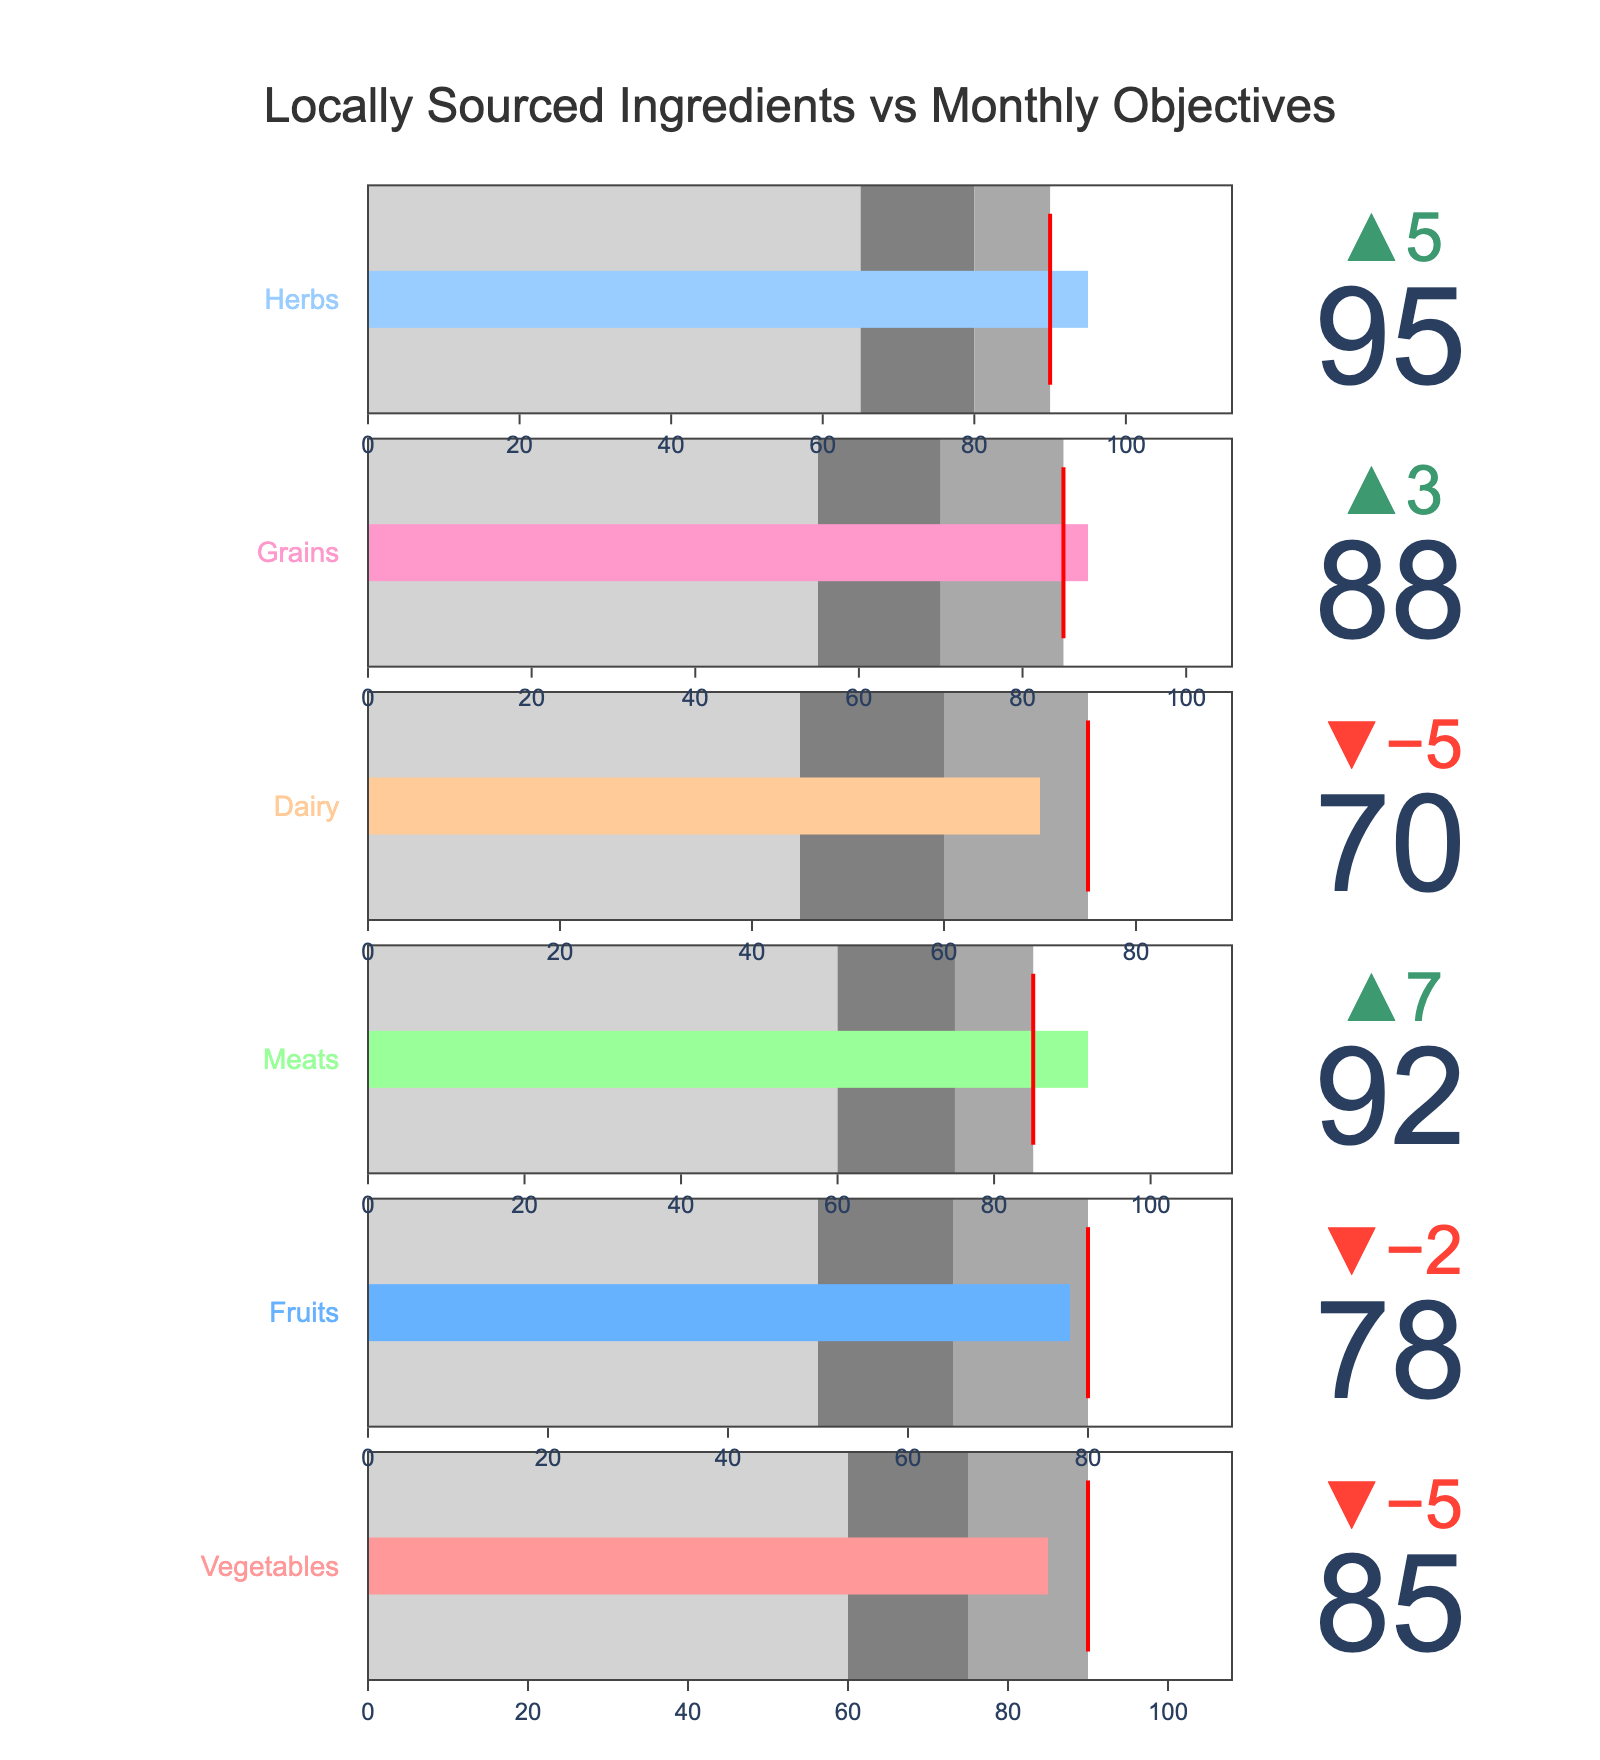How many categories are displayed in the chart? By counting each bullet graph, we see that there are separate graphs for Vegetables, Fruits, Meats, Dairy, Grains, and Herbs.
Answer: 6 What is the title of the chart? The title is located at the top of the figure and reads "Locally Sourced Ingredients vs Monthly Objectives".
Answer: Locally Sourced Ingredients vs Monthly Objectives Which category has the highest percentage of locally sourced ingredients? By observing the bullet charts, the Meats category shows the highest value with an Actual percentage of 92%.
Answer: Meats Which category falls the furthest below its target? To determine this, compute the differences between each Actual and Target value: Vegetables (-5), Fruits (-2), Meats (+7), Dairy (-5), Grains (+3), Herbs (+5). The category with the largest negative difference is Vegetables with a difference of -5 points.
Answer: Vegetables What is the range of the darkest gray area for Fruits? Each category has three shaded regions, with the darkest indicating the highest range. For Fruits, these are 50 to 65 (light gray), 65 to 80 (gray), and 80+ (dark gray). Since the Targets are used as endpoints, the darkest gray range for Fruits stops at its Target value of 80.
Answer: 65-80 Which categories achieved their target values? By checking each bullet's delta indicator for positive values or equality: Vegetables (-5), Fruits (-2), Meats (+7), Dairy (-5), Grains (+3), and Herbs (+5). Meats, Grains, and Herbs meet or exceed their targets.
Answer: Meats, Grains, Herbs What is the average of the Actual percentages for all categories? Sum the Actual percentages and divide by the number of categories: (85 + 78 + 92 + 70 + 88 + 95) / 6 = 84.67.
Answer: 84.67 Which category has the largest range between its lowest and highest range values? Calculate for each: Vegetables (90-60 = 30), Fruits (80-50 = 30), Meats (85-60 = 25), Dairy (75-45 = 30), Grains (85-55 = 30), Herbs (90-65 = 25). Vegetables, Fruits, Dairy, and Grains all have a maximum range of 30 points.
Answer: Vegetables, Fruits, Dairy, Grains Which colors are used for the bullet graph bars, and what categories do they represent? Identify the color-coded bars from the description: Vegetables (red), Fruits (blue), Meats (green), Dairy (orange), Grains (pink), and Herbs (light blue).
Answer: Red: Vegetables, Blue: Fruits, Green: Meats, Orange: Dairy, Pink: Grains, Light Blue: Herbs 